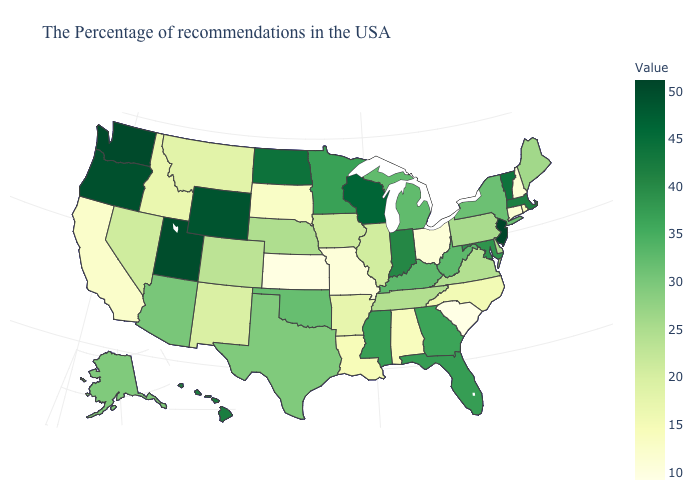Among the states that border New Jersey , which have the lowest value?
Give a very brief answer. Delaware. Does the map have missing data?
Short answer required. No. Does New Jersey have the highest value in the USA?
Answer briefly. Yes. Which states have the highest value in the USA?
Keep it brief. New Jersey. Does the map have missing data?
Quick response, please. No. 